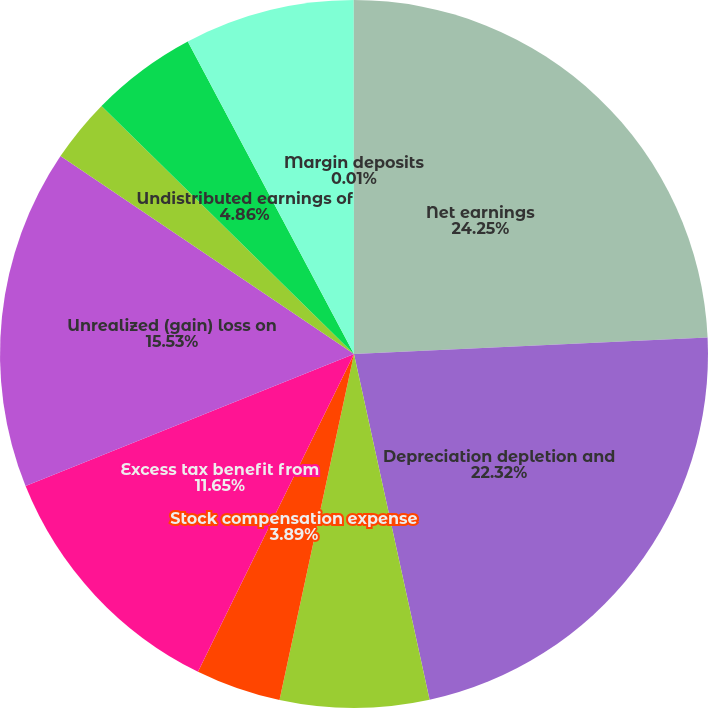<chart> <loc_0><loc_0><loc_500><loc_500><pie_chart><fcel>Net earnings<fcel>Depreciation depletion and<fcel>Deferred income taxes<fcel>Stock compensation expense<fcel>Excess tax benefit from<fcel>Unrealized (gain) loss on<fcel>Loss on disposal of property<fcel>Undistributed earnings of<fcel>Accounts receivable<fcel>Margin deposits<nl><fcel>24.26%<fcel>22.32%<fcel>6.8%<fcel>3.89%<fcel>11.65%<fcel>15.53%<fcel>2.92%<fcel>4.86%<fcel>7.77%<fcel>0.01%<nl></chart> 